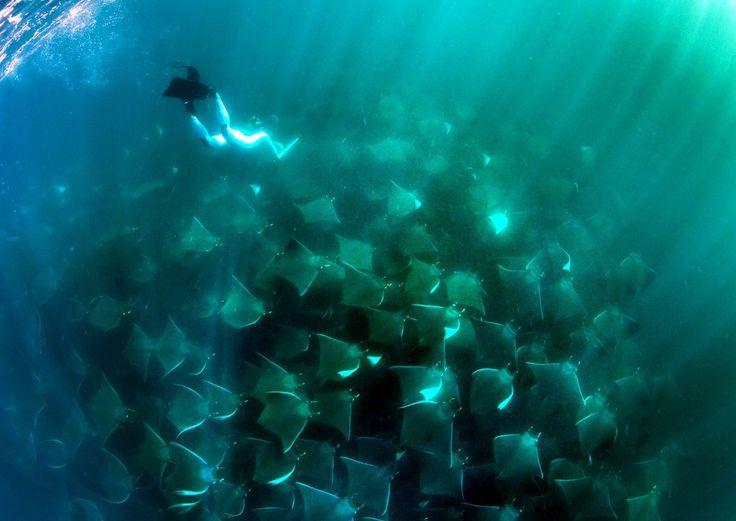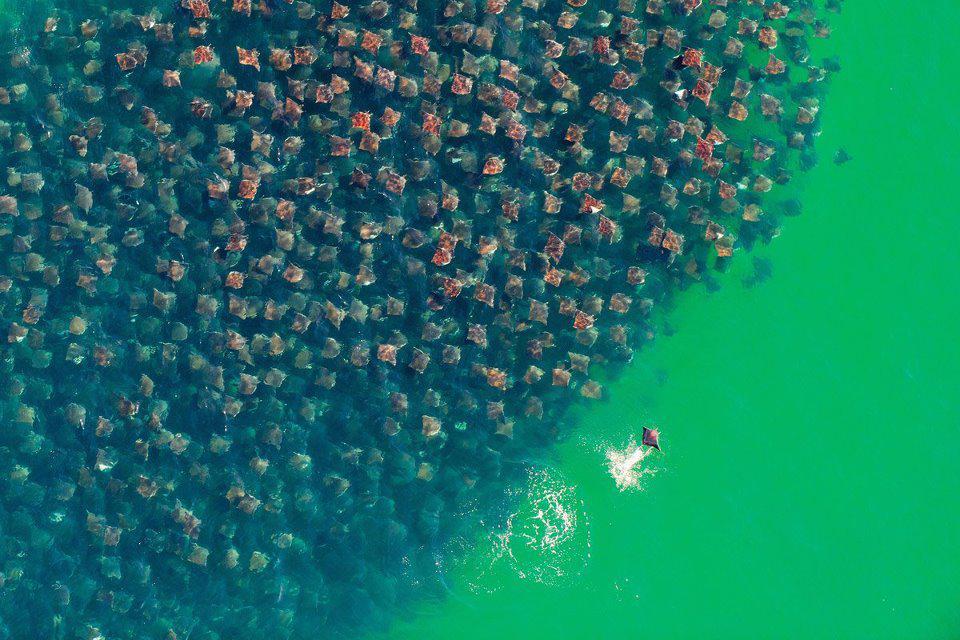The first image is the image on the left, the second image is the image on the right. For the images shown, is this caption "There are no more than 8 creatures in the image on the right." true? Answer yes or no. No. 